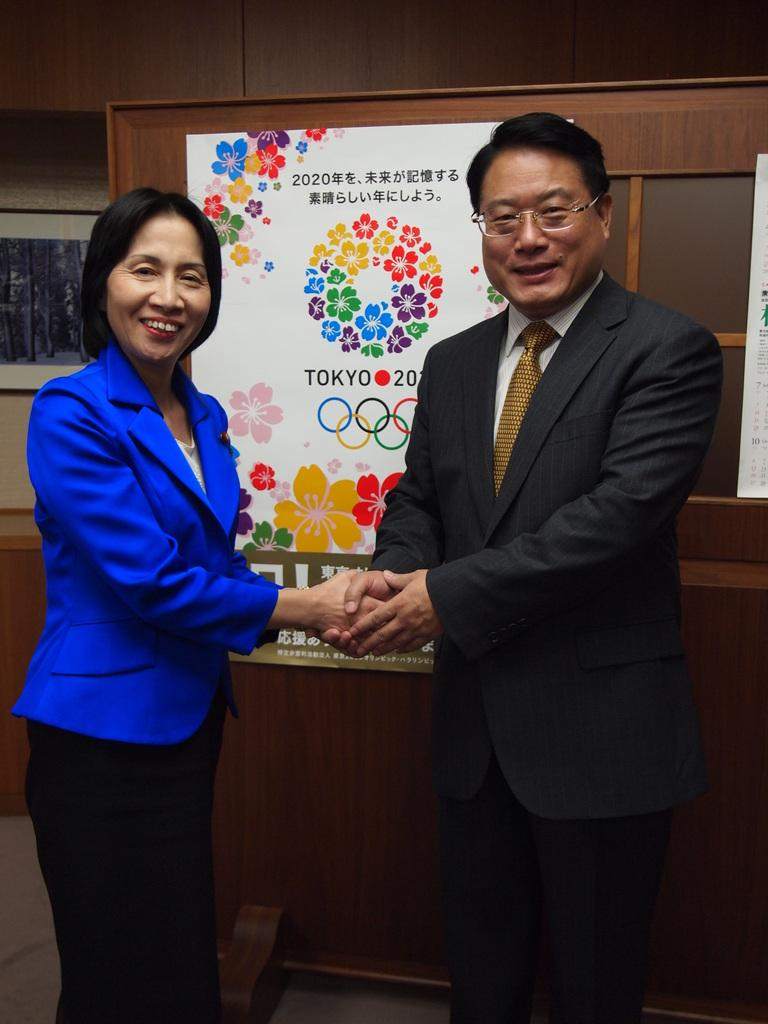Who is present in the image? There is a man and a woman in the image. What are the man and the woman wearing? Both the man and the woman are wearing coats. What is the facial expression of the man and the woman? The man and the woman are smiling. What can be seen in the background of the image? There is a poster visible in the background of the image. What flavor of ice cream can be seen in the man's hand in the image? There is no ice cream present in the image, so it is not possible to determine the flavor. 